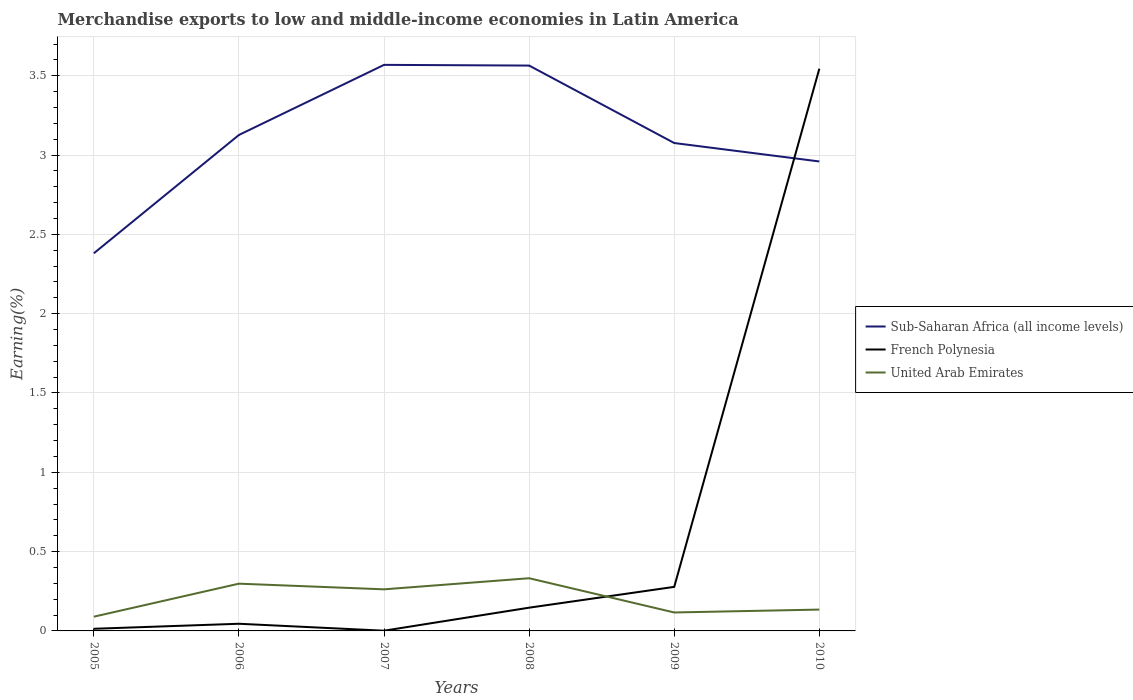Across all years, what is the maximum percentage of amount earned from merchandise exports in United Arab Emirates?
Offer a very short reply. 0.09. What is the total percentage of amount earned from merchandise exports in French Polynesia in the graph?
Make the answer very short. -0.03. What is the difference between the highest and the second highest percentage of amount earned from merchandise exports in French Polynesia?
Make the answer very short. 3.54. What is the difference between the highest and the lowest percentage of amount earned from merchandise exports in United Arab Emirates?
Provide a succinct answer. 3. Is the percentage of amount earned from merchandise exports in Sub-Saharan Africa (all income levels) strictly greater than the percentage of amount earned from merchandise exports in French Polynesia over the years?
Make the answer very short. No. How many years are there in the graph?
Provide a succinct answer. 6. What is the difference between two consecutive major ticks on the Y-axis?
Provide a short and direct response. 0.5. Are the values on the major ticks of Y-axis written in scientific E-notation?
Give a very brief answer. No. Does the graph contain grids?
Keep it short and to the point. Yes. How many legend labels are there?
Keep it short and to the point. 3. What is the title of the graph?
Ensure brevity in your answer.  Merchandise exports to low and middle-income economies in Latin America. Does "United States" appear as one of the legend labels in the graph?
Make the answer very short. No. What is the label or title of the X-axis?
Ensure brevity in your answer.  Years. What is the label or title of the Y-axis?
Offer a terse response. Earning(%). What is the Earning(%) in Sub-Saharan Africa (all income levels) in 2005?
Offer a very short reply. 2.38. What is the Earning(%) in French Polynesia in 2005?
Give a very brief answer. 0.01. What is the Earning(%) in United Arab Emirates in 2005?
Offer a terse response. 0.09. What is the Earning(%) of Sub-Saharan Africa (all income levels) in 2006?
Provide a succinct answer. 3.13. What is the Earning(%) of French Polynesia in 2006?
Your answer should be compact. 0.05. What is the Earning(%) of United Arab Emirates in 2006?
Your answer should be compact. 0.3. What is the Earning(%) of Sub-Saharan Africa (all income levels) in 2007?
Provide a short and direct response. 3.57. What is the Earning(%) of French Polynesia in 2007?
Your response must be concise. 0. What is the Earning(%) of United Arab Emirates in 2007?
Provide a succinct answer. 0.26. What is the Earning(%) in Sub-Saharan Africa (all income levels) in 2008?
Your answer should be compact. 3.56. What is the Earning(%) in French Polynesia in 2008?
Keep it short and to the point. 0.15. What is the Earning(%) in United Arab Emirates in 2008?
Ensure brevity in your answer.  0.33. What is the Earning(%) in Sub-Saharan Africa (all income levels) in 2009?
Offer a terse response. 3.08. What is the Earning(%) in French Polynesia in 2009?
Give a very brief answer. 0.28. What is the Earning(%) of United Arab Emirates in 2009?
Offer a terse response. 0.12. What is the Earning(%) in Sub-Saharan Africa (all income levels) in 2010?
Offer a very short reply. 2.96. What is the Earning(%) in French Polynesia in 2010?
Provide a succinct answer. 3.54. What is the Earning(%) in United Arab Emirates in 2010?
Provide a short and direct response. 0.13. Across all years, what is the maximum Earning(%) of Sub-Saharan Africa (all income levels)?
Give a very brief answer. 3.57. Across all years, what is the maximum Earning(%) of French Polynesia?
Offer a very short reply. 3.54. Across all years, what is the maximum Earning(%) in United Arab Emirates?
Offer a terse response. 0.33. Across all years, what is the minimum Earning(%) of Sub-Saharan Africa (all income levels)?
Keep it short and to the point. 2.38. Across all years, what is the minimum Earning(%) of French Polynesia?
Provide a short and direct response. 0. Across all years, what is the minimum Earning(%) in United Arab Emirates?
Your answer should be very brief. 0.09. What is the total Earning(%) in Sub-Saharan Africa (all income levels) in the graph?
Give a very brief answer. 18.68. What is the total Earning(%) in French Polynesia in the graph?
Your answer should be compact. 4.03. What is the total Earning(%) in United Arab Emirates in the graph?
Make the answer very short. 1.23. What is the difference between the Earning(%) of Sub-Saharan Africa (all income levels) in 2005 and that in 2006?
Your answer should be compact. -0.75. What is the difference between the Earning(%) of French Polynesia in 2005 and that in 2006?
Offer a terse response. -0.03. What is the difference between the Earning(%) in United Arab Emirates in 2005 and that in 2006?
Make the answer very short. -0.21. What is the difference between the Earning(%) in Sub-Saharan Africa (all income levels) in 2005 and that in 2007?
Make the answer very short. -1.19. What is the difference between the Earning(%) in French Polynesia in 2005 and that in 2007?
Offer a very short reply. 0.01. What is the difference between the Earning(%) of United Arab Emirates in 2005 and that in 2007?
Ensure brevity in your answer.  -0.17. What is the difference between the Earning(%) of Sub-Saharan Africa (all income levels) in 2005 and that in 2008?
Offer a terse response. -1.18. What is the difference between the Earning(%) of French Polynesia in 2005 and that in 2008?
Give a very brief answer. -0.13. What is the difference between the Earning(%) of United Arab Emirates in 2005 and that in 2008?
Your answer should be compact. -0.24. What is the difference between the Earning(%) of Sub-Saharan Africa (all income levels) in 2005 and that in 2009?
Your answer should be compact. -0.7. What is the difference between the Earning(%) of French Polynesia in 2005 and that in 2009?
Keep it short and to the point. -0.26. What is the difference between the Earning(%) in United Arab Emirates in 2005 and that in 2009?
Offer a terse response. -0.03. What is the difference between the Earning(%) of Sub-Saharan Africa (all income levels) in 2005 and that in 2010?
Ensure brevity in your answer.  -0.58. What is the difference between the Earning(%) of French Polynesia in 2005 and that in 2010?
Your response must be concise. -3.53. What is the difference between the Earning(%) of United Arab Emirates in 2005 and that in 2010?
Ensure brevity in your answer.  -0.04. What is the difference between the Earning(%) in Sub-Saharan Africa (all income levels) in 2006 and that in 2007?
Your answer should be very brief. -0.44. What is the difference between the Earning(%) of French Polynesia in 2006 and that in 2007?
Keep it short and to the point. 0.04. What is the difference between the Earning(%) in United Arab Emirates in 2006 and that in 2007?
Ensure brevity in your answer.  0.04. What is the difference between the Earning(%) in Sub-Saharan Africa (all income levels) in 2006 and that in 2008?
Provide a succinct answer. -0.44. What is the difference between the Earning(%) in French Polynesia in 2006 and that in 2008?
Keep it short and to the point. -0.1. What is the difference between the Earning(%) of United Arab Emirates in 2006 and that in 2008?
Provide a succinct answer. -0.03. What is the difference between the Earning(%) in Sub-Saharan Africa (all income levels) in 2006 and that in 2009?
Make the answer very short. 0.05. What is the difference between the Earning(%) of French Polynesia in 2006 and that in 2009?
Ensure brevity in your answer.  -0.23. What is the difference between the Earning(%) in United Arab Emirates in 2006 and that in 2009?
Ensure brevity in your answer.  0.18. What is the difference between the Earning(%) in Sub-Saharan Africa (all income levels) in 2006 and that in 2010?
Your answer should be very brief. 0.17. What is the difference between the Earning(%) of French Polynesia in 2006 and that in 2010?
Give a very brief answer. -3.5. What is the difference between the Earning(%) in United Arab Emirates in 2006 and that in 2010?
Give a very brief answer. 0.16. What is the difference between the Earning(%) in Sub-Saharan Africa (all income levels) in 2007 and that in 2008?
Provide a succinct answer. 0. What is the difference between the Earning(%) of French Polynesia in 2007 and that in 2008?
Give a very brief answer. -0.15. What is the difference between the Earning(%) in United Arab Emirates in 2007 and that in 2008?
Offer a very short reply. -0.07. What is the difference between the Earning(%) of Sub-Saharan Africa (all income levels) in 2007 and that in 2009?
Your answer should be compact. 0.49. What is the difference between the Earning(%) in French Polynesia in 2007 and that in 2009?
Provide a succinct answer. -0.28. What is the difference between the Earning(%) of United Arab Emirates in 2007 and that in 2009?
Offer a very short reply. 0.15. What is the difference between the Earning(%) of Sub-Saharan Africa (all income levels) in 2007 and that in 2010?
Offer a very short reply. 0.61. What is the difference between the Earning(%) in French Polynesia in 2007 and that in 2010?
Offer a terse response. -3.54. What is the difference between the Earning(%) of United Arab Emirates in 2007 and that in 2010?
Give a very brief answer. 0.13. What is the difference between the Earning(%) of Sub-Saharan Africa (all income levels) in 2008 and that in 2009?
Keep it short and to the point. 0.49. What is the difference between the Earning(%) of French Polynesia in 2008 and that in 2009?
Provide a short and direct response. -0.13. What is the difference between the Earning(%) in United Arab Emirates in 2008 and that in 2009?
Provide a succinct answer. 0.22. What is the difference between the Earning(%) in Sub-Saharan Africa (all income levels) in 2008 and that in 2010?
Offer a very short reply. 0.6. What is the difference between the Earning(%) of French Polynesia in 2008 and that in 2010?
Ensure brevity in your answer.  -3.4. What is the difference between the Earning(%) in United Arab Emirates in 2008 and that in 2010?
Provide a short and direct response. 0.2. What is the difference between the Earning(%) in Sub-Saharan Africa (all income levels) in 2009 and that in 2010?
Your response must be concise. 0.12. What is the difference between the Earning(%) in French Polynesia in 2009 and that in 2010?
Your answer should be very brief. -3.27. What is the difference between the Earning(%) in United Arab Emirates in 2009 and that in 2010?
Offer a very short reply. -0.02. What is the difference between the Earning(%) in Sub-Saharan Africa (all income levels) in 2005 and the Earning(%) in French Polynesia in 2006?
Offer a very short reply. 2.34. What is the difference between the Earning(%) in Sub-Saharan Africa (all income levels) in 2005 and the Earning(%) in United Arab Emirates in 2006?
Offer a very short reply. 2.08. What is the difference between the Earning(%) of French Polynesia in 2005 and the Earning(%) of United Arab Emirates in 2006?
Your response must be concise. -0.28. What is the difference between the Earning(%) in Sub-Saharan Africa (all income levels) in 2005 and the Earning(%) in French Polynesia in 2007?
Your answer should be very brief. 2.38. What is the difference between the Earning(%) of Sub-Saharan Africa (all income levels) in 2005 and the Earning(%) of United Arab Emirates in 2007?
Offer a very short reply. 2.12. What is the difference between the Earning(%) of French Polynesia in 2005 and the Earning(%) of United Arab Emirates in 2007?
Provide a succinct answer. -0.25. What is the difference between the Earning(%) in Sub-Saharan Africa (all income levels) in 2005 and the Earning(%) in French Polynesia in 2008?
Make the answer very short. 2.23. What is the difference between the Earning(%) in Sub-Saharan Africa (all income levels) in 2005 and the Earning(%) in United Arab Emirates in 2008?
Make the answer very short. 2.05. What is the difference between the Earning(%) in French Polynesia in 2005 and the Earning(%) in United Arab Emirates in 2008?
Your answer should be compact. -0.32. What is the difference between the Earning(%) of Sub-Saharan Africa (all income levels) in 2005 and the Earning(%) of French Polynesia in 2009?
Offer a very short reply. 2.1. What is the difference between the Earning(%) of Sub-Saharan Africa (all income levels) in 2005 and the Earning(%) of United Arab Emirates in 2009?
Your response must be concise. 2.26. What is the difference between the Earning(%) in French Polynesia in 2005 and the Earning(%) in United Arab Emirates in 2009?
Your answer should be very brief. -0.1. What is the difference between the Earning(%) in Sub-Saharan Africa (all income levels) in 2005 and the Earning(%) in French Polynesia in 2010?
Offer a terse response. -1.16. What is the difference between the Earning(%) in Sub-Saharan Africa (all income levels) in 2005 and the Earning(%) in United Arab Emirates in 2010?
Keep it short and to the point. 2.25. What is the difference between the Earning(%) of French Polynesia in 2005 and the Earning(%) of United Arab Emirates in 2010?
Ensure brevity in your answer.  -0.12. What is the difference between the Earning(%) of Sub-Saharan Africa (all income levels) in 2006 and the Earning(%) of French Polynesia in 2007?
Provide a short and direct response. 3.13. What is the difference between the Earning(%) in Sub-Saharan Africa (all income levels) in 2006 and the Earning(%) in United Arab Emirates in 2007?
Your answer should be compact. 2.86. What is the difference between the Earning(%) in French Polynesia in 2006 and the Earning(%) in United Arab Emirates in 2007?
Offer a terse response. -0.22. What is the difference between the Earning(%) of Sub-Saharan Africa (all income levels) in 2006 and the Earning(%) of French Polynesia in 2008?
Make the answer very short. 2.98. What is the difference between the Earning(%) in Sub-Saharan Africa (all income levels) in 2006 and the Earning(%) in United Arab Emirates in 2008?
Your answer should be very brief. 2.79. What is the difference between the Earning(%) of French Polynesia in 2006 and the Earning(%) of United Arab Emirates in 2008?
Offer a terse response. -0.29. What is the difference between the Earning(%) in Sub-Saharan Africa (all income levels) in 2006 and the Earning(%) in French Polynesia in 2009?
Your response must be concise. 2.85. What is the difference between the Earning(%) in Sub-Saharan Africa (all income levels) in 2006 and the Earning(%) in United Arab Emirates in 2009?
Offer a terse response. 3.01. What is the difference between the Earning(%) of French Polynesia in 2006 and the Earning(%) of United Arab Emirates in 2009?
Provide a short and direct response. -0.07. What is the difference between the Earning(%) in Sub-Saharan Africa (all income levels) in 2006 and the Earning(%) in French Polynesia in 2010?
Provide a short and direct response. -0.42. What is the difference between the Earning(%) of Sub-Saharan Africa (all income levels) in 2006 and the Earning(%) of United Arab Emirates in 2010?
Offer a very short reply. 2.99. What is the difference between the Earning(%) in French Polynesia in 2006 and the Earning(%) in United Arab Emirates in 2010?
Provide a short and direct response. -0.09. What is the difference between the Earning(%) of Sub-Saharan Africa (all income levels) in 2007 and the Earning(%) of French Polynesia in 2008?
Provide a short and direct response. 3.42. What is the difference between the Earning(%) of Sub-Saharan Africa (all income levels) in 2007 and the Earning(%) of United Arab Emirates in 2008?
Give a very brief answer. 3.24. What is the difference between the Earning(%) in French Polynesia in 2007 and the Earning(%) in United Arab Emirates in 2008?
Ensure brevity in your answer.  -0.33. What is the difference between the Earning(%) in Sub-Saharan Africa (all income levels) in 2007 and the Earning(%) in French Polynesia in 2009?
Give a very brief answer. 3.29. What is the difference between the Earning(%) of Sub-Saharan Africa (all income levels) in 2007 and the Earning(%) of United Arab Emirates in 2009?
Ensure brevity in your answer.  3.45. What is the difference between the Earning(%) in French Polynesia in 2007 and the Earning(%) in United Arab Emirates in 2009?
Your response must be concise. -0.12. What is the difference between the Earning(%) in Sub-Saharan Africa (all income levels) in 2007 and the Earning(%) in French Polynesia in 2010?
Offer a terse response. 0.02. What is the difference between the Earning(%) of Sub-Saharan Africa (all income levels) in 2007 and the Earning(%) of United Arab Emirates in 2010?
Ensure brevity in your answer.  3.43. What is the difference between the Earning(%) in French Polynesia in 2007 and the Earning(%) in United Arab Emirates in 2010?
Keep it short and to the point. -0.13. What is the difference between the Earning(%) of Sub-Saharan Africa (all income levels) in 2008 and the Earning(%) of French Polynesia in 2009?
Keep it short and to the point. 3.29. What is the difference between the Earning(%) in Sub-Saharan Africa (all income levels) in 2008 and the Earning(%) in United Arab Emirates in 2009?
Your answer should be compact. 3.45. What is the difference between the Earning(%) in French Polynesia in 2008 and the Earning(%) in United Arab Emirates in 2009?
Keep it short and to the point. 0.03. What is the difference between the Earning(%) in Sub-Saharan Africa (all income levels) in 2008 and the Earning(%) in French Polynesia in 2010?
Keep it short and to the point. 0.02. What is the difference between the Earning(%) of Sub-Saharan Africa (all income levels) in 2008 and the Earning(%) of United Arab Emirates in 2010?
Ensure brevity in your answer.  3.43. What is the difference between the Earning(%) of French Polynesia in 2008 and the Earning(%) of United Arab Emirates in 2010?
Ensure brevity in your answer.  0.01. What is the difference between the Earning(%) in Sub-Saharan Africa (all income levels) in 2009 and the Earning(%) in French Polynesia in 2010?
Your response must be concise. -0.47. What is the difference between the Earning(%) in Sub-Saharan Africa (all income levels) in 2009 and the Earning(%) in United Arab Emirates in 2010?
Your answer should be compact. 2.94. What is the difference between the Earning(%) in French Polynesia in 2009 and the Earning(%) in United Arab Emirates in 2010?
Give a very brief answer. 0.14. What is the average Earning(%) of Sub-Saharan Africa (all income levels) per year?
Your answer should be very brief. 3.11. What is the average Earning(%) in French Polynesia per year?
Offer a terse response. 0.67. What is the average Earning(%) in United Arab Emirates per year?
Your answer should be compact. 0.21. In the year 2005, what is the difference between the Earning(%) of Sub-Saharan Africa (all income levels) and Earning(%) of French Polynesia?
Your answer should be compact. 2.37. In the year 2005, what is the difference between the Earning(%) in Sub-Saharan Africa (all income levels) and Earning(%) in United Arab Emirates?
Provide a short and direct response. 2.29. In the year 2005, what is the difference between the Earning(%) in French Polynesia and Earning(%) in United Arab Emirates?
Provide a short and direct response. -0.08. In the year 2006, what is the difference between the Earning(%) in Sub-Saharan Africa (all income levels) and Earning(%) in French Polynesia?
Make the answer very short. 3.08. In the year 2006, what is the difference between the Earning(%) in Sub-Saharan Africa (all income levels) and Earning(%) in United Arab Emirates?
Your answer should be compact. 2.83. In the year 2006, what is the difference between the Earning(%) in French Polynesia and Earning(%) in United Arab Emirates?
Offer a terse response. -0.25. In the year 2007, what is the difference between the Earning(%) of Sub-Saharan Africa (all income levels) and Earning(%) of French Polynesia?
Give a very brief answer. 3.57. In the year 2007, what is the difference between the Earning(%) in Sub-Saharan Africa (all income levels) and Earning(%) in United Arab Emirates?
Provide a short and direct response. 3.31. In the year 2007, what is the difference between the Earning(%) in French Polynesia and Earning(%) in United Arab Emirates?
Ensure brevity in your answer.  -0.26. In the year 2008, what is the difference between the Earning(%) of Sub-Saharan Africa (all income levels) and Earning(%) of French Polynesia?
Your response must be concise. 3.42. In the year 2008, what is the difference between the Earning(%) in Sub-Saharan Africa (all income levels) and Earning(%) in United Arab Emirates?
Offer a very short reply. 3.23. In the year 2008, what is the difference between the Earning(%) of French Polynesia and Earning(%) of United Arab Emirates?
Offer a very short reply. -0.19. In the year 2009, what is the difference between the Earning(%) in Sub-Saharan Africa (all income levels) and Earning(%) in French Polynesia?
Your answer should be very brief. 2.8. In the year 2009, what is the difference between the Earning(%) in Sub-Saharan Africa (all income levels) and Earning(%) in United Arab Emirates?
Your response must be concise. 2.96. In the year 2009, what is the difference between the Earning(%) in French Polynesia and Earning(%) in United Arab Emirates?
Give a very brief answer. 0.16. In the year 2010, what is the difference between the Earning(%) of Sub-Saharan Africa (all income levels) and Earning(%) of French Polynesia?
Your response must be concise. -0.58. In the year 2010, what is the difference between the Earning(%) in Sub-Saharan Africa (all income levels) and Earning(%) in United Arab Emirates?
Keep it short and to the point. 2.83. In the year 2010, what is the difference between the Earning(%) of French Polynesia and Earning(%) of United Arab Emirates?
Your answer should be very brief. 3.41. What is the ratio of the Earning(%) of Sub-Saharan Africa (all income levels) in 2005 to that in 2006?
Your answer should be very brief. 0.76. What is the ratio of the Earning(%) of French Polynesia in 2005 to that in 2006?
Your answer should be compact. 0.3. What is the ratio of the Earning(%) of United Arab Emirates in 2005 to that in 2006?
Provide a short and direct response. 0.3. What is the ratio of the Earning(%) in Sub-Saharan Africa (all income levels) in 2005 to that in 2007?
Ensure brevity in your answer.  0.67. What is the ratio of the Earning(%) of French Polynesia in 2005 to that in 2007?
Your answer should be very brief. 9.95. What is the ratio of the Earning(%) of United Arab Emirates in 2005 to that in 2007?
Ensure brevity in your answer.  0.34. What is the ratio of the Earning(%) of Sub-Saharan Africa (all income levels) in 2005 to that in 2008?
Offer a terse response. 0.67. What is the ratio of the Earning(%) of French Polynesia in 2005 to that in 2008?
Give a very brief answer. 0.09. What is the ratio of the Earning(%) of United Arab Emirates in 2005 to that in 2008?
Your answer should be very brief. 0.27. What is the ratio of the Earning(%) in Sub-Saharan Africa (all income levels) in 2005 to that in 2009?
Provide a short and direct response. 0.77. What is the ratio of the Earning(%) of French Polynesia in 2005 to that in 2009?
Offer a very short reply. 0.05. What is the ratio of the Earning(%) in United Arab Emirates in 2005 to that in 2009?
Your answer should be very brief. 0.77. What is the ratio of the Earning(%) in Sub-Saharan Africa (all income levels) in 2005 to that in 2010?
Your response must be concise. 0.8. What is the ratio of the Earning(%) in French Polynesia in 2005 to that in 2010?
Offer a very short reply. 0. What is the ratio of the Earning(%) in United Arab Emirates in 2005 to that in 2010?
Ensure brevity in your answer.  0.67. What is the ratio of the Earning(%) of Sub-Saharan Africa (all income levels) in 2006 to that in 2007?
Provide a short and direct response. 0.88. What is the ratio of the Earning(%) of French Polynesia in 2006 to that in 2007?
Your response must be concise. 33.4. What is the ratio of the Earning(%) of United Arab Emirates in 2006 to that in 2007?
Ensure brevity in your answer.  1.14. What is the ratio of the Earning(%) of Sub-Saharan Africa (all income levels) in 2006 to that in 2008?
Ensure brevity in your answer.  0.88. What is the ratio of the Earning(%) in French Polynesia in 2006 to that in 2008?
Make the answer very short. 0.31. What is the ratio of the Earning(%) of United Arab Emirates in 2006 to that in 2008?
Give a very brief answer. 0.9. What is the ratio of the Earning(%) of Sub-Saharan Africa (all income levels) in 2006 to that in 2009?
Your answer should be very brief. 1.02. What is the ratio of the Earning(%) in French Polynesia in 2006 to that in 2009?
Provide a succinct answer. 0.16. What is the ratio of the Earning(%) of United Arab Emirates in 2006 to that in 2009?
Your response must be concise. 2.56. What is the ratio of the Earning(%) of Sub-Saharan Africa (all income levels) in 2006 to that in 2010?
Your response must be concise. 1.06. What is the ratio of the Earning(%) of French Polynesia in 2006 to that in 2010?
Offer a very short reply. 0.01. What is the ratio of the Earning(%) of United Arab Emirates in 2006 to that in 2010?
Provide a short and direct response. 2.21. What is the ratio of the Earning(%) in Sub-Saharan Africa (all income levels) in 2007 to that in 2008?
Offer a very short reply. 1. What is the ratio of the Earning(%) of French Polynesia in 2007 to that in 2008?
Keep it short and to the point. 0.01. What is the ratio of the Earning(%) of United Arab Emirates in 2007 to that in 2008?
Your response must be concise. 0.79. What is the ratio of the Earning(%) of Sub-Saharan Africa (all income levels) in 2007 to that in 2009?
Give a very brief answer. 1.16. What is the ratio of the Earning(%) of French Polynesia in 2007 to that in 2009?
Provide a short and direct response. 0. What is the ratio of the Earning(%) in United Arab Emirates in 2007 to that in 2009?
Make the answer very short. 2.25. What is the ratio of the Earning(%) in Sub-Saharan Africa (all income levels) in 2007 to that in 2010?
Your answer should be very brief. 1.21. What is the ratio of the Earning(%) in French Polynesia in 2007 to that in 2010?
Keep it short and to the point. 0. What is the ratio of the Earning(%) of United Arab Emirates in 2007 to that in 2010?
Keep it short and to the point. 1.95. What is the ratio of the Earning(%) of Sub-Saharan Africa (all income levels) in 2008 to that in 2009?
Ensure brevity in your answer.  1.16. What is the ratio of the Earning(%) in French Polynesia in 2008 to that in 2009?
Keep it short and to the point. 0.53. What is the ratio of the Earning(%) of United Arab Emirates in 2008 to that in 2009?
Ensure brevity in your answer.  2.86. What is the ratio of the Earning(%) of Sub-Saharan Africa (all income levels) in 2008 to that in 2010?
Offer a terse response. 1.2. What is the ratio of the Earning(%) in French Polynesia in 2008 to that in 2010?
Give a very brief answer. 0.04. What is the ratio of the Earning(%) of United Arab Emirates in 2008 to that in 2010?
Your response must be concise. 2.47. What is the ratio of the Earning(%) in Sub-Saharan Africa (all income levels) in 2009 to that in 2010?
Keep it short and to the point. 1.04. What is the ratio of the Earning(%) in French Polynesia in 2009 to that in 2010?
Your answer should be very brief. 0.08. What is the ratio of the Earning(%) in United Arab Emirates in 2009 to that in 2010?
Your response must be concise. 0.86. What is the difference between the highest and the second highest Earning(%) in Sub-Saharan Africa (all income levels)?
Provide a short and direct response. 0. What is the difference between the highest and the second highest Earning(%) of French Polynesia?
Your response must be concise. 3.27. What is the difference between the highest and the second highest Earning(%) in United Arab Emirates?
Provide a short and direct response. 0.03. What is the difference between the highest and the lowest Earning(%) of Sub-Saharan Africa (all income levels)?
Offer a very short reply. 1.19. What is the difference between the highest and the lowest Earning(%) in French Polynesia?
Provide a succinct answer. 3.54. What is the difference between the highest and the lowest Earning(%) of United Arab Emirates?
Your answer should be very brief. 0.24. 